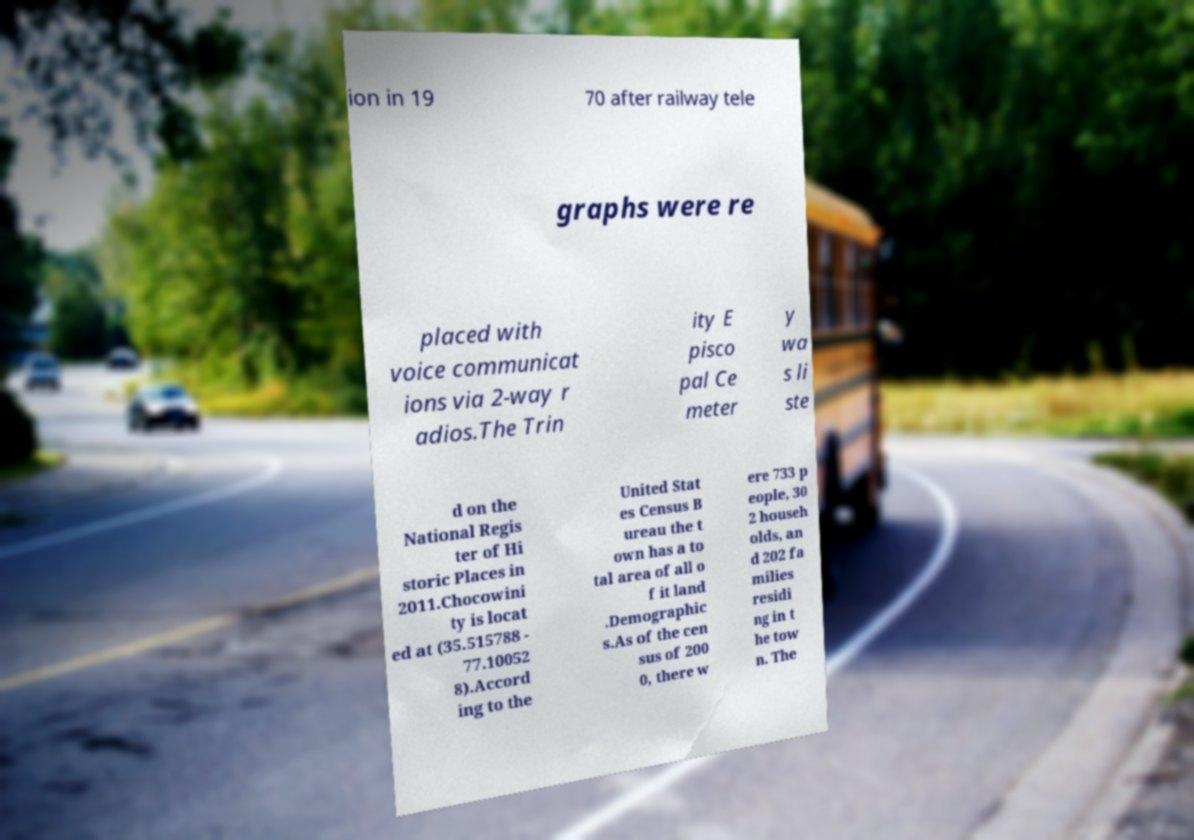Could you extract and type out the text from this image? ion in 19 70 after railway tele graphs were re placed with voice communicat ions via 2-way r adios.The Trin ity E pisco pal Ce meter y wa s li ste d on the National Regis ter of Hi storic Places in 2011.Chocowini ty is locat ed at (35.515788 - 77.10052 8).Accord ing to the United Stat es Census B ureau the t own has a to tal area of all o f it land .Demographic s.As of the cen sus of 200 0, there w ere 733 p eople, 30 2 househ olds, an d 202 fa milies residi ng in t he tow n. The 